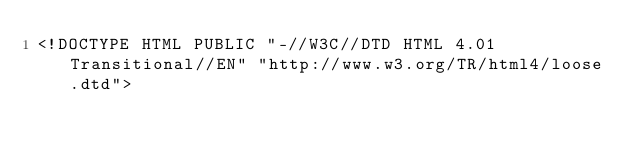Convert code to text. <code><loc_0><loc_0><loc_500><loc_500><_HTML_><!DOCTYPE HTML PUBLIC "-//W3C//DTD HTML 4.01 Transitional//EN" "http://www.w3.org/TR/html4/loose.dtd"></code> 